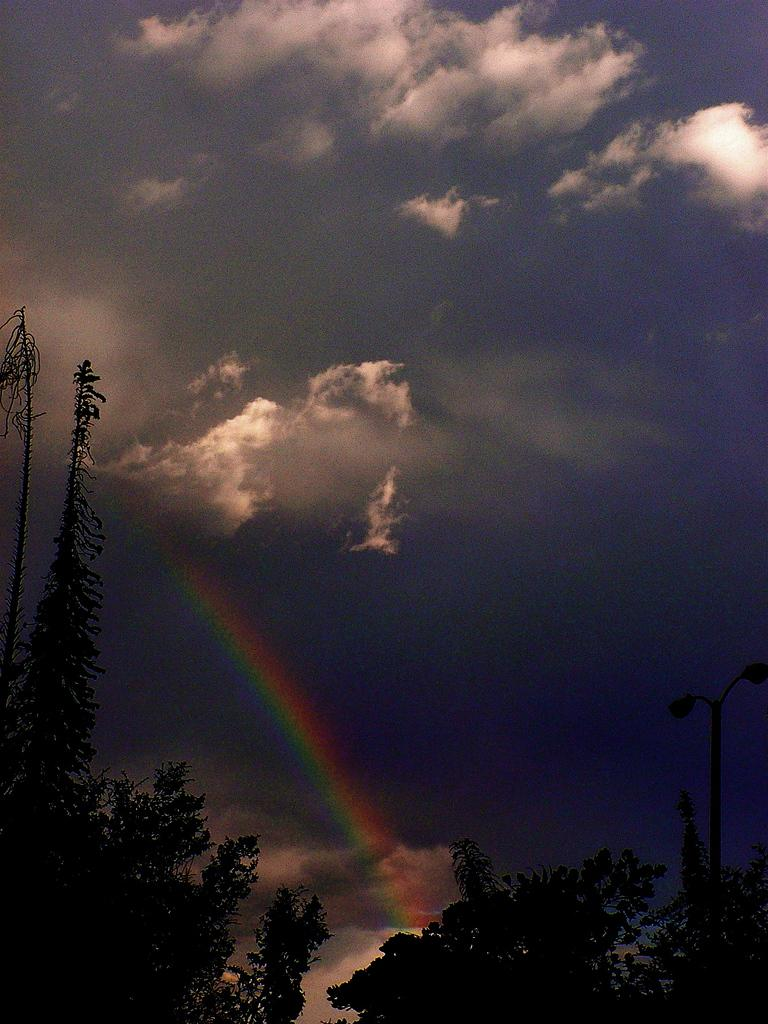What type of vegetation is present at the bottom of the image? There are trees at the bottom of the image. What can be seen in the background of the image? There are clouds and a rainbow in the blue sky in the background of the image. What date is marked on the calendar in the image? There is no calendar present in the image. Can you see the zebra's arm in the image? There is no zebra present in the image. 